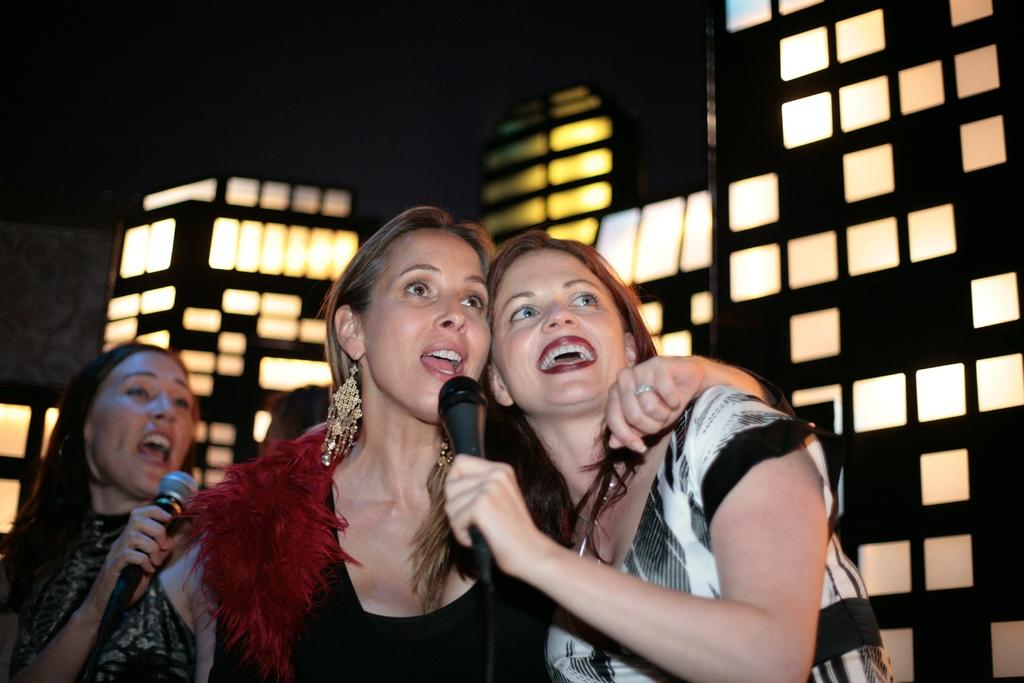How many people are in the image? There are three women in the image. What are the women holding in the image? The women are holding microphones. What activity are the women engaged in? The women are singing. Can you describe the background of the image? There is a wall with a design in the background of the image. What type of throne can be seen in the image? There is no throne present in the image. How many chairs are visible in the image? There is no mention of chairs in the image; it features three women singing with microphones. 